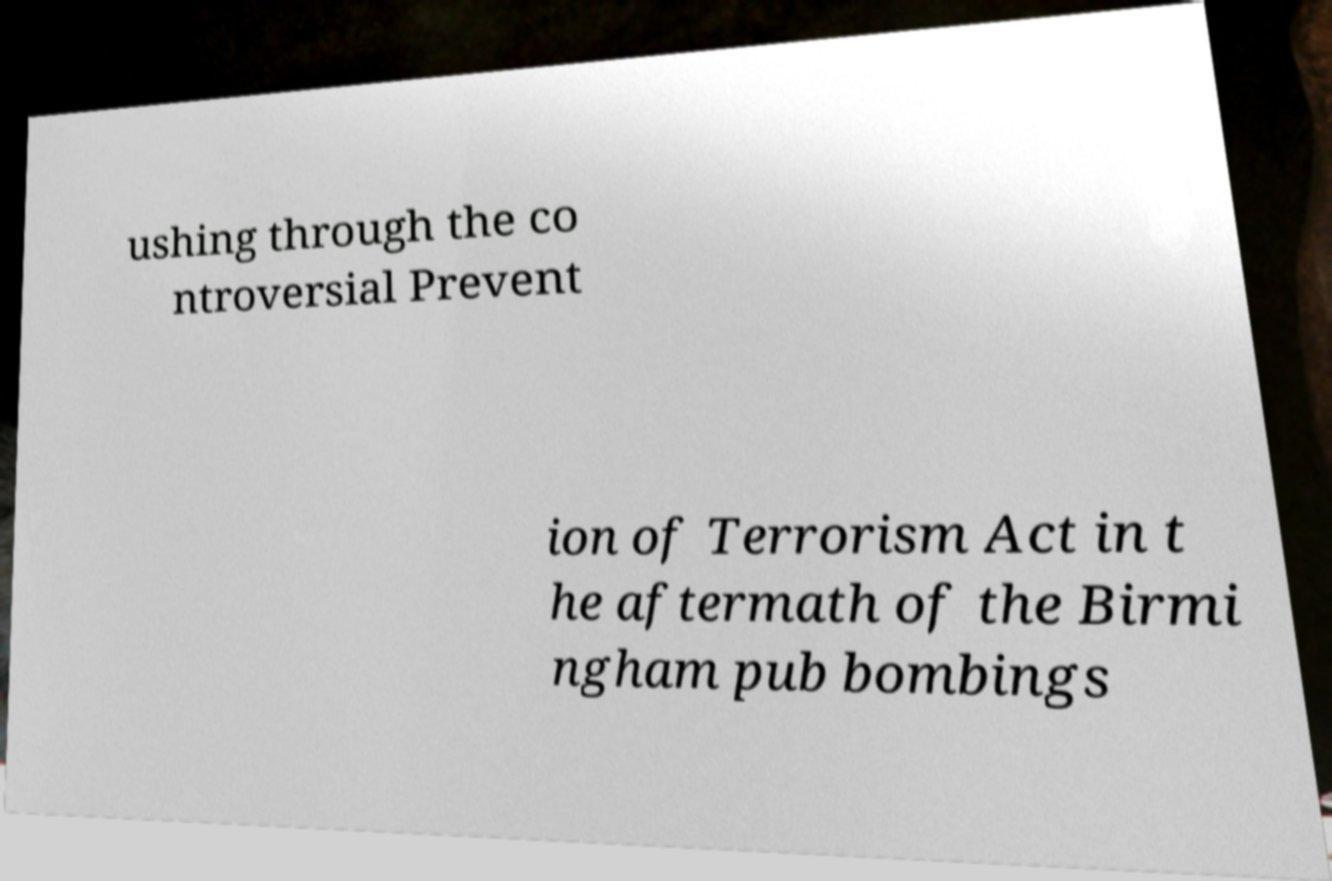Could you assist in decoding the text presented in this image and type it out clearly? ushing through the co ntroversial Prevent ion of Terrorism Act in t he aftermath of the Birmi ngham pub bombings 